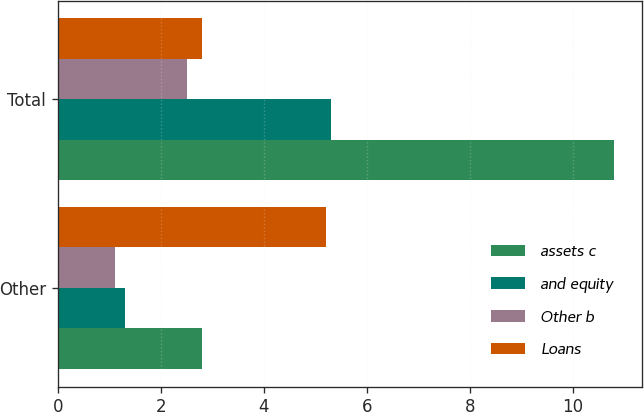Convert chart. <chart><loc_0><loc_0><loc_500><loc_500><stacked_bar_chart><ecel><fcel>Other<fcel>Total<nl><fcel>assets c<fcel>2.8<fcel>10.8<nl><fcel>and equity<fcel>1.3<fcel>5.3<nl><fcel>Other b<fcel>1.1<fcel>2.5<nl><fcel>Loans<fcel>5.2<fcel>2.8<nl></chart> 